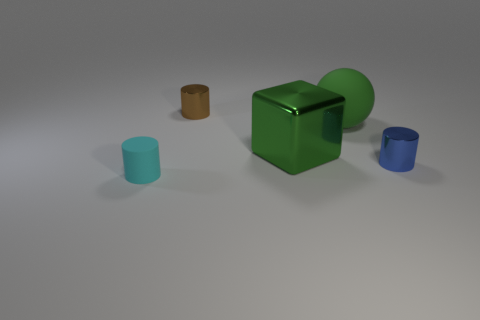Are there an equal number of big rubber objects on the left side of the big rubber ball and tiny metallic cylinders that are in front of the blue cylinder?
Your response must be concise. Yes. What is the color of the thing that is made of the same material as the cyan cylinder?
Provide a succinct answer. Green. Is there a big green ball made of the same material as the brown thing?
Your response must be concise. No. How many things are tiny rubber cylinders or cylinders?
Make the answer very short. 3. Is the sphere made of the same material as the tiny brown thing to the left of the big rubber ball?
Make the answer very short. No. There is a shiny cylinder behind the small blue object; what size is it?
Your response must be concise. Small. Is the number of green metallic objects less than the number of yellow metal balls?
Keep it short and to the point. No. Is there a big metallic block of the same color as the tiny rubber thing?
Provide a succinct answer. No. What shape is the metal object that is right of the small brown metal thing and on the left side of the large matte sphere?
Offer a terse response. Cube. There is a object in front of the tiny metal object right of the cube; what shape is it?
Keep it short and to the point. Cylinder. 